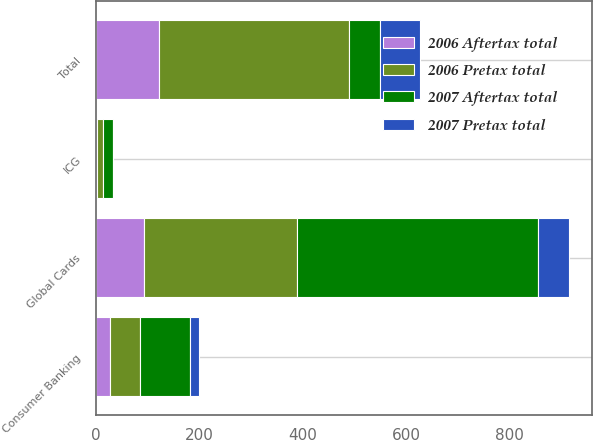Convert chart. <chart><loc_0><loc_0><loc_500><loc_500><stacked_bar_chart><ecel><fcel>Global Cards<fcel>Consumer Banking<fcel>ICG<fcel>Total<nl><fcel>2007 Aftertax total<fcel>466<fcel>96<fcel>19<fcel>59<nl><fcel>2006 Pretax total<fcel>296<fcel>59<fcel>12<fcel>367<nl><fcel>2006 Aftertax total<fcel>94<fcel>27<fcel>2<fcel>123<nl><fcel>2007 Pretax total<fcel>59<fcel>18<fcel>1<fcel>78<nl></chart> 